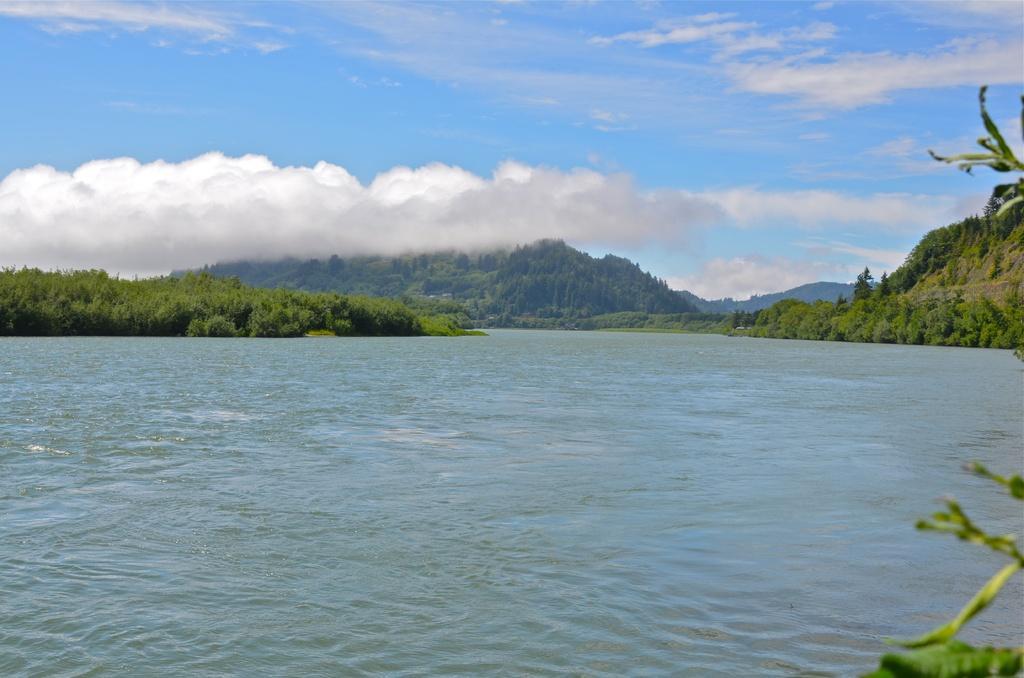Could you give a brief overview of what you see in this image? In this image, we can see a river. There are plants and hills in the middle of the image. There are clouds in the sky. 